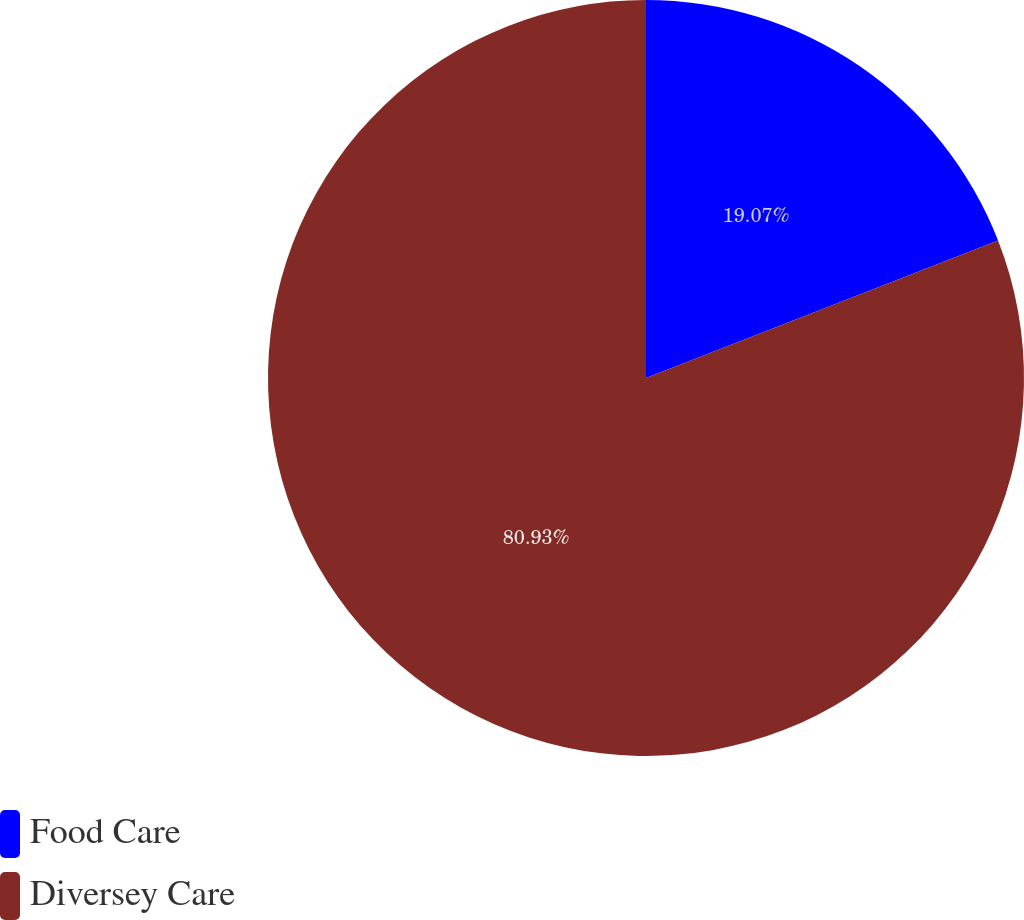Convert chart to OTSL. <chart><loc_0><loc_0><loc_500><loc_500><pie_chart><fcel>Food Care<fcel>Diversey Care<nl><fcel>19.07%<fcel>80.93%<nl></chart> 